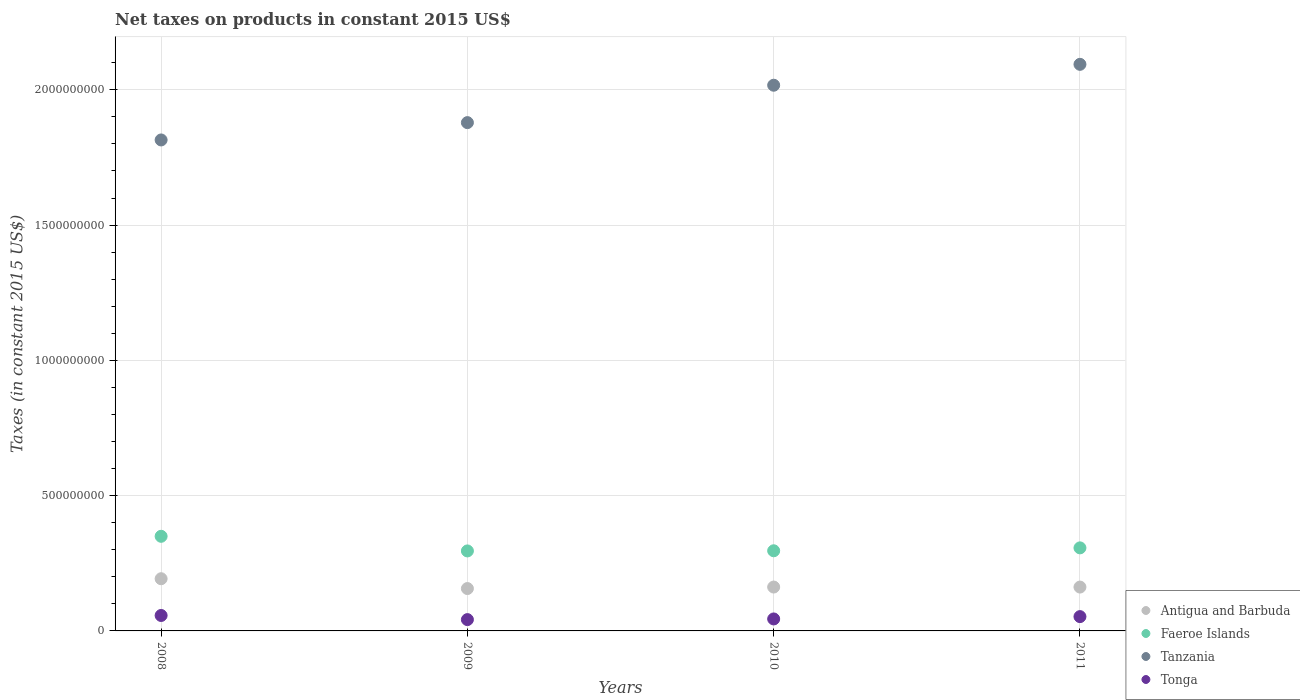Is the number of dotlines equal to the number of legend labels?
Your response must be concise. Yes. What is the net taxes on products in Antigua and Barbuda in 2011?
Make the answer very short. 1.62e+08. Across all years, what is the maximum net taxes on products in Tonga?
Offer a very short reply. 5.71e+07. Across all years, what is the minimum net taxes on products in Tanzania?
Provide a short and direct response. 1.81e+09. In which year was the net taxes on products in Tonga minimum?
Your answer should be compact. 2009. What is the total net taxes on products in Tanzania in the graph?
Ensure brevity in your answer.  7.80e+09. What is the difference between the net taxes on products in Antigua and Barbuda in 2008 and that in 2009?
Provide a succinct answer. 3.63e+07. What is the difference between the net taxes on products in Faeroe Islands in 2011 and the net taxes on products in Antigua and Barbuda in 2010?
Provide a succinct answer. 1.45e+08. What is the average net taxes on products in Tonga per year?
Make the answer very short. 4.90e+07. In the year 2010, what is the difference between the net taxes on products in Tanzania and net taxes on products in Antigua and Barbuda?
Provide a succinct answer. 1.85e+09. In how many years, is the net taxes on products in Faeroe Islands greater than 1600000000 US$?
Make the answer very short. 0. What is the ratio of the net taxes on products in Tanzania in 2009 to that in 2010?
Your answer should be very brief. 0.93. Is the difference between the net taxes on products in Tanzania in 2009 and 2011 greater than the difference between the net taxes on products in Antigua and Barbuda in 2009 and 2011?
Your answer should be compact. No. What is the difference between the highest and the second highest net taxes on products in Tanzania?
Your answer should be very brief. 7.72e+07. What is the difference between the highest and the lowest net taxes on products in Faeroe Islands?
Provide a succinct answer. 5.41e+07. In how many years, is the net taxes on products in Tanzania greater than the average net taxes on products in Tanzania taken over all years?
Keep it short and to the point. 2. Is it the case that in every year, the sum of the net taxes on products in Faeroe Islands and net taxes on products in Antigua and Barbuda  is greater than the net taxes on products in Tanzania?
Your response must be concise. No. Does the net taxes on products in Antigua and Barbuda monotonically increase over the years?
Offer a very short reply. No. Is the net taxes on products in Tanzania strictly greater than the net taxes on products in Antigua and Barbuda over the years?
Keep it short and to the point. Yes. Is the net taxes on products in Faeroe Islands strictly less than the net taxes on products in Tonga over the years?
Provide a short and direct response. No. How many years are there in the graph?
Provide a succinct answer. 4. What is the difference between two consecutive major ticks on the Y-axis?
Your response must be concise. 5.00e+08. Are the values on the major ticks of Y-axis written in scientific E-notation?
Provide a succinct answer. No. How many legend labels are there?
Provide a succinct answer. 4. How are the legend labels stacked?
Keep it short and to the point. Vertical. What is the title of the graph?
Your answer should be compact. Net taxes on products in constant 2015 US$. What is the label or title of the X-axis?
Your response must be concise. Years. What is the label or title of the Y-axis?
Keep it short and to the point. Taxes (in constant 2015 US$). What is the Taxes (in constant 2015 US$) in Antigua and Barbuda in 2008?
Your response must be concise. 1.93e+08. What is the Taxes (in constant 2015 US$) of Faeroe Islands in 2008?
Give a very brief answer. 3.50e+08. What is the Taxes (in constant 2015 US$) of Tanzania in 2008?
Ensure brevity in your answer.  1.81e+09. What is the Taxes (in constant 2015 US$) in Tonga in 2008?
Your answer should be very brief. 5.71e+07. What is the Taxes (in constant 2015 US$) of Antigua and Barbuda in 2009?
Keep it short and to the point. 1.57e+08. What is the Taxes (in constant 2015 US$) of Faeroe Islands in 2009?
Provide a succinct answer. 2.96e+08. What is the Taxes (in constant 2015 US$) of Tanzania in 2009?
Your answer should be compact. 1.88e+09. What is the Taxes (in constant 2015 US$) in Tonga in 2009?
Offer a very short reply. 4.18e+07. What is the Taxes (in constant 2015 US$) of Antigua and Barbuda in 2010?
Ensure brevity in your answer.  1.62e+08. What is the Taxes (in constant 2015 US$) in Faeroe Islands in 2010?
Provide a succinct answer. 2.96e+08. What is the Taxes (in constant 2015 US$) in Tanzania in 2010?
Keep it short and to the point. 2.02e+09. What is the Taxes (in constant 2015 US$) of Tonga in 2010?
Your answer should be very brief. 4.43e+07. What is the Taxes (in constant 2015 US$) in Antigua and Barbuda in 2011?
Ensure brevity in your answer.  1.62e+08. What is the Taxes (in constant 2015 US$) of Faeroe Islands in 2011?
Your response must be concise. 3.07e+08. What is the Taxes (in constant 2015 US$) of Tanzania in 2011?
Give a very brief answer. 2.09e+09. What is the Taxes (in constant 2015 US$) in Tonga in 2011?
Your response must be concise. 5.29e+07. Across all years, what is the maximum Taxes (in constant 2015 US$) of Antigua and Barbuda?
Provide a short and direct response. 1.93e+08. Across all years, what is the maximum Taxes (in constant 2015 US$) of Faeroe Islands?
Your answer should be compact. 3.50e+08. Across all years, what is the maximum Taxes (in constant 2015 US$) of Tanzania?
Provide a short and direct response. 2.09e+09. Across all years, what is the maximum Taxes (in constant 2015 US$) of Tonga?
Your answer should be very brief. 5.71e+07. Across all years, what is the minimum Taxes (in constant 2015 US$) of Antigua and Barbuda?
Make the answer very short. 1.57e+08. Across all years, what is the minimum Taxes (in constant 2015 US$) of Faeroe Islands?
Your answer should be compact. 2.96e+08. Across all years, what is the minimum Taxes (in constant 2015 US$) of Tanzania?
Your answer should be very brief. 1.81e+09. Across all years, what is the minimum Taxes (in constant 2015 US$) of Tonga?
Offer a terse response. 4.18e+07. What is the total Taxes (in constant 2015 US$) of Antigua and Barbuda in the graph?
Provide a short and direct response. 6.74e+08. What is the total Taxes (in constant 2015 US$) of Faeroe Islands in the graph?
Offer a very short reply. 1.25e+09. What is the total Taxes (in constant 2015 US$) of Tanzania in the graph?
Make the answer very short. 7.80e+09. What is the total Taxes (in constant 2015 US$) in Tonga in the graph?
Ensure brevity in your answer.  1.96e+08. What is the difference between the Taxes (in constant 2015 US$) of Antigua and Barbuda in 2008 and that in 2009?
Provide a short and direct response. 3.63e+07. What is the difference between the Taxes (in constant 2015 US$) of Faeroe Islands in 2008 and that in 2009?
Your answer should be very brief. 5.41e+07. What is the difference between the Taxes (in constant 2015 US$) in Tanzania in 2008 and that in 2009?
Your response must be concise. -6.40e+07. What is the difference between the Taxes (in constant 2015 US$) in Tonga in 2008 and that in 2009?
Ensure brevity in your answer.  1.53e+07. What is the difference between the Taxes (in constant 2015 US$) of Antigua and Barbuda in 2008 and that in 2010?
Offer a very short reply. 3.07e+07. What is the difference between the Taxes (in constant 2015 US$) in Faeroe Islands in 2008 and that in 2010?
Offer a terse response. 5.35e+07. What is the difference between the Taxes (in constant 2015 US$) of Tanzania in 2008 and that in 2010?
Give a very brief answer. -2.02e+08. What is the difference between the Taxes (in constant 2015 US$) of Tonga in 2008 and that in 2010?
Provide a succinct answer. 1.28e+07. What is the difference between the Taxes (in constant 2015 US$) of Antigua and Barbuda in 2008 and that in 2011?
Provide a short and direct response. 3.08e+07. What is the difference between the Taxes (in constant 2015 US$) in Faeroe Islands in 2008 and that in 2011?
Ensure brevity in your answer.  4.28e+07. What is the difference between the Taxes (in constant 2015 US$) in Tanzania in 2008 and that in 2011?
Keep it short and to the point. -2.79e+08. What is the difference between the Taxes (in constant 2015 US$) of Tonga in 2008 and that in 2011?
Your response must be concise. 4.20e+06. What is the difference between the Taxes (in constant 2015 US$) in Antigua and Barbuda in 2009 and that in 2010?
Offer a very short reply. -5.54e+06. What is the difference between the Taxes (in constant 2015 US$) in Faeroe Islands in 2009 and that in 2010?
Ensure brevity in your answer.  -5.65e+05. What is the difference between the Taxes (in constant 2015 US$) of Tanzania in 2009 and that in 2010?
Provide a succinct answer. -1.38e+08. What is the difference between the Taxes (in constant 2015 US$) of Tonga in 2009 and that in 2010?
Make the answer very short. -2.45e+06. What is the difference between the Taxes (in constant 2015 US$) of Antigua and Barbuda in 2009 and that in 2011?
Make the answer very short. -5.46e+06. What is the difference between the Taxes (in constant 2015 US$) of Faeroe Islands in 2009 and that in 2011?
Your response must be concise. -1.13e+07. What is the difference between the Taxes (in constant 2015 US$) in Tanzania in 2009 and that in 2011?
Your response must be concise. -2.15e+08. What is the difference between the Taxes (in constant 2015 US$) of Tonga in 2009 and that in 2011?
Your answer should be compact. -1.11e+07. What is the difference between the Taxes (in constant 2015 US$) in Antigua and Barbuda in 2010 and that in 2011?
Offer a very short reply. 8.18e+04. What is the difference between the Taxes (in constant 2015 US$) in Faeroe Islands in 2010 and that in 2011?
Offer a very short reply. -1.07e+07. What is the difference between the Taxes (in constant 2015 US$) in Tanzania in 2010 and that in 2011?
Make the answer very short. -7.72e+07. What is the difference between the Taxes (in constant 2015 US$) of Tonga in 2010 and that in 2011?
Give a very brief answer. -8.62e+06. What is the difference between the Taxes (in constant 2015 US$) in Antigua and Barbuda in 2008 and the Taxes (in constant 2015 US$) in Faeroe Islands in 2009?
Your answer should be compact. -1.03e+08. What is the difference between the Taxes (in constant 2015 US$) in Antigua and Barbuda in 2008 and the Taxes (in constant 2015 US$) in Tanzania in 2009?
Keep it short and to the point. -1.69e+09. What is the difference between the Taxes (in constant 2015 US$) in Antigua and Barbuda in 2008 and the Taxes (in constant 2015 US$) in Tonga in 2009?
Ensure brevity in your answer.  1.51e+08. What is the difference between the Taxes (in constant 2015 US$) in Faeroe Islands in 2008 and the Taxes (in constant 2015 US$) in Tanzania in 2009?
Make the answer very short. -1.53e+09. What is the difference between the Taxes (in constant 2015 US$) in Faeroe Islands in 2008 and the Taxes (in constant 2015 US$) in Tonga in 2009?
Your answer should be compact. 3.08e+08. What is the difference between the Taxes (in constant 2015 US$) of Tanzania in 2008 and the Taxes (in constant 2015 US$) of Tonga in 2009?
Provide a succinct answer. 1.77e+09. What is the difference between the Taxes (in constant 2015 US$) in Antigua and Barbuda in 2008 and the Taxes (in constant 2015 US$) in Faeroe Islands in 2010?
Your response must be concise. -1.03e+08. What is the difference between the Taxes (in constant 2015 US$) of Antigua and Barbuda in 2008 and the Taxes (in constant 2015 US$) of Tanzania in 2010?
Give a very brief answer. -1.82e+09. What is the difference between the Taxes (in constant 2015 US$) in Antigua and Barbuda in 2008 and the Taxes (in constant 2015 US$) in Tonga in 2010?
Your response must be concise. 1.49e+08. What is the difference between the Taxes (in constant 2015 US$) in Faeroe Islands in 2008 and the Taxes (in constant 2015 US$) in Tanzania in 2010?
Provide a short and direct response. -1.67e+09. What is the difference between the Taxes (in constant 2015 US$) of Faeroe Islands in 2008 and the Taxes (in constant 2015 US$) of Tonga in 2010?
Provide a succinct answer. 3.05e+08. What is the difference between the Taxes (in constant 2015 US$) in Tanzania in 2008 and the Taxes (in constant 2015 US$) in Tonga in 2010?
Your answer should be compact. 1.77e+09. What is the difference between the Taxes (in constant 2015 US$) in Antigua and Barbuda in 2008 and the Taxes (in constant 2015 US$) in Faeroe Islands in 2011?
Your answer should be very brief. -1.14e+08. What is the difference between the Taxes (in constant 2015 US$) in Antigua and Barbuda in 2008 and the Taxes (in constant 2015 US$) in Tanzania in 2011?
Offer a terse response. -1.90e+09. What is the difference between the Taxes (in constant 2015 US$) of Antigua and Barbuda in 2008 and the Taxes (in constant 2015 US$) of Tonga in 2011?
Your answer should be compact. 1.40e+08. What is the difference between the Taxes (in constant 2015 US$) of Faeroe Islands in 2008 and the Taxes (in constant 2015 US$) of Tanzania in 2011?
Provide a succinct answer. -1.74e+09. What is the difference between the Taxes (in constant 2015 US$) of Faeroe Islands in 2008 and the Taxes (in constant 2015 US$) of Tonga in 2011?
Provide a succinct answer. 2.97e+08. What is the difference between the Taxes (in constant 2015 US$) of Tanzania in 2008 and the Taxes (in constant 2015 US$) of Tonga in 2011?
Your response must be concise. 1.76e+09. What is the difference between the Taxes (in constant 2015 US$) in Antigua and Barbuda in 2009 and the Taxes (in constant 2015 US$) in Faeroe Islands in 2010?
Keep it short and to the point. -1.40e+08. What is the difference between the Taxes (in constant 2015 US$) of Antigua and Barbuda in 2009 and the Taxes (in constant 2015 US$) of Tanzania in 2010?
Provide a succinct answer. -1.86e+09. What is the difference between the Taxes (in constant 2015 US$) of Antigua and Barbuda in 2009 and the Taxes (in constant 2015 US$) of Tonga in 2010?
Keep it short and to the point. 1.12e+08. What is the difference between the Taxes (in constant 2015 US$) of Faeroe Islands in 2009 and the Taxes (in constant 2015 US$) of Tanzania in 2010?
Offer a very short reply. -1.72e+09. What is the difference between the Taxes (in constant 2015 US$) in Faeroe Islands in 2009 and the Taxes (in constant 2015 US$) in Tonga in 2010?
Your answer should be very brief. 2.51e+08. What is the difference between the Taxes (in constant 2015 US$) in Tanzania in 2009 and the Taxes (in constant 2015 US$) in Tonga in 2010?
Keep it short and to the point. 1.83e+09. What is the difference between the Taxes (in constant 2015 US$) in Antigua and Barbuda in 2009 and the Taxes (in constant 2015 US$) in Faeroe Islands in 2011?
Offer a very short reply. -1.50e+08. What is the difference between the Taxes (in constant 2015 US$) in Antigua and Barbuda in 2009 and the Taxes (in constant 2015 US$) in Tanzania in 2011?
Your response must be concise. -1.94e+09. What is the difference between the Taxes (in constant 2015 US$) of Antigua and Barbuda in 2009 and the Taxes (in constant 2015 US$) of Tonga in 2011?
Provide a short and direct response. 1.04e+08. What is the difference between the Taxes (in constant 2015 US$) in Faeroe Islands in 2009 and the Taxes (in constant 2015 US$) in Tanzania in 2011?
Give a very brief answer. -1.80e+09. What is the difference between the Taxes (in constant 2015 US$) of Faeroe Islands in 2009 and the Taxes (in constant 2015 US$) of Tonga in 2011?
Keep it short and to the point. 2.43e+08. What is the difference between the Taxes (in constant 2015 US$) in Tanzania in 2009 and the Taxes (in constant 2015 US$) in Tonga in 2011?
Your response must be concise. 1.83e+09. What is the difference between the Taxes (in constant 2015 US$) in Antigua and Barbuda in 2010 and the Taxes (in constant 2015 US$) in Faeroe Islands in 2011?
Your answer should be very brief. -1.45e+08. What is the difference between the Taxes (in constant 2015 US$) of Antigua and Barbuda in 2010 and the Taxes (in constant 2015 US$) of Tanzania in 2011?
Provide a succinct answer. -1.93e+09. What is the difference between the Taxes (in constant 2015 US$) of Antigua and Barbuda in 2010 and the Taxes (in constant 2015 US$) of Tonga in 2011?
Offer a very short reply. 1.09e+08. What is the difference between the Taxes (in constant 2015 US$) of Faeroe Islands in 2010 and the Taxes (in constant 2015 US$) of Tanzania in 2011?
Your answer should be very brief. -1.80e+09. What is the difference between the Taxes (in constant 2015 US$) in Faeroe Islands in 2010 and the Taxes (in constant 2015 US$) in Tonga in 2011?
Provide a short and direct response. 2.43e+08. What is the difference between the Taxes (in constant 2015 US$) of Tanzania in 2010 and the Taxes (in constant 2015 US$) of Tonga in 2011?
Provide a short and direct response. 1.96e+09. What is the average Taxes (in constant 2015 US$) of Antigua and Barbuda per year?
Give a very brief answer. 1.68e+08. What is the average Taxes (in constant 2015 US$) of Faeroe Islands per year?
Your answer should be very brief. 3.12e+08. What is the average Taxes (in constant 2015 US$) of Tanzania per year?
Provide a succinct answer. 1.95e+09. What is the average Taxes (in constant 2015 US$) in Tonga per year?
Your answer should be very brief. 4.90e+07. In the year 2008, what is the difference between the Taxes (in constant 2015 US$) in Antigua and Barbuda and Taxes (in constant 2015 US$) in Faeroe Islands?
Provide a short and direct response. -1.57e+08. In the year 2008, what is the difference between the Taxes (in constant 2015 US$) in Antigua and Barbuda and Taxes (in constant 2015 US$) in Tanzania?
Offer a terse response. -1.62e+09. In the year 2008, what is the difference between the Taxes (in constant 2015 US$) in Antigua and Barbuda and Taxes (in constant 2015 US$) in Tonga?
Ensure brevity in your answer.  1.36e+08. In the year 2008, what is the difference between the Taxes (in constant 2015 US$) in Faeroe Islands and Taxes (in constant 2015 US$) in Tanzania?
Your answer should be compact. -1.46e+09. In the year 2008, what is the difference between the Taxes (in constant 2015 US$) in Faeroe Islands and Taxes (in constant 2015 US$) in Tonga?
Your response must be concise. 2.93e+08. In the year 2008, what is the difference between the Taxes (in constant 2015 US$) in Tanzania and Taxes (in constant 2015 US$) in Tonga?
Give a very brief answer. 1.76e+09. In the year 2009, what is the difference between the Taxes (in constant 2015 US$) of Antigua and Barbuda and Taxes (in constant 2015 US$) of Faeroe Islands?
Keep it short and to the point. -1.39e+08. In the year 2009, what is the difference between the Taxes (in constant 2015 US$) of Antigua and Barbuda and Taxes (in constant 2015 US$) of Tanzania?
Provide a succinct answer. -1.72e+09. In the year 2009, what is the difference between the Taxes (in constant 2015 US$) of Antigua and Barbuda and Taxes (in constant 2015 US$) of Tonga?
Ensure brevity in your answer.  1.15e+08. In the year 2009, what is the difference between the Taxes (in constant 2015 US$) of Faeroe Islands and Taxes (in constant 2015 US$) of Tanzania?
Give a very brief answer. -1.58e+09. In the year 2009, what is the difference between the Taxes (in constant 2015 US$) of Faeroe Islands and Taxes (in constant 2015 US$) of Tonga?
Your answer should be very brief. 2.54e+08. In the year 2009, what is the difference between the Taxes (in constant 2015 US$) of Tanzania and Taxes (in constant 2015 US$) of Tonga?
Give a very brief answer. 1.84e+09. In the year 2010, what is the difference between the Taxes (in constant 2015 US$) in Antigua and Barbuda and Taxes (in constant 2015 US$) in Faeroe Islands?
Offer a terse response. -1.34e+08. In the year 2010, what is the difference between the Taxes (in constant 2015 US$) of Antigua and Barbuda and Taxes (in constant 2015 US$) of Tanzania?
Give a very brief answer. -1.85e+09. In the year 2010, what is the difference between the Taxes (in constant 2015 US$) in Antigua and Barbuda and Taxes (in constant 2015 US$) in Tonga?
Offer a very short reply. 1.18e+08. In the year 2010, what is the difference between the Taxes (in constant 2015 US$) in Faeroe Islands and Taxes (in constant 2015 US$) in Tanzania?
Make the answer very short. -1.72e+09. In the year 2010, what is the difference between the Taxes (in constant 2015 US$) in Faeroe Islands and Taxes (in constant 2015 US$) in Tonga?
Offer a terse response. 2.52e+08. In the year 2010, what is the difference between the Taxes (in constant 2015 US$) in Tanzania and Taxes (in constant 2015 US$) in Tonga?
Offer a terse response. 1.97e+09. In the year 2011, what is the difference between the Taxes (in constant 2015 US$) in Antigua and Barbuda and Taxes (in constant 2015 US$) in Faeroe Islands?
Give a very brief answer. -1.45e+08. In the year 2011, what is the difference between the Taxes (in constant 2015 US$) of Antigua and Barbuda and Taxes (in constant 2015 US$) of Tanzania?
Your answer should be very brief. -1.93e+09. In the year 2011, what is the difference between the Taxes (in constant 2015 US$) in Antigua and Barbuda and Taxes (in constant 2015 US$) in Tonga?
Your answer should be very brief. 1.09e+08. In the year 2011, what is the difference between the Taxes (in constant 2015 US$) of Faeroe Islands and Taxes (in constant 2015 US$) of Tanzania?
Keep it short and to the point. -1.79e+09. In the year 2011, what is the difference between the Taxes (in constant 2015 US$) in Faeroe Islands and Taxes (in constant 2015 US$) in Tonga?
Make the answer very short. 2.54e+08. In the year 2011, what is the difference between the Taxes (in constant 2015 US$) in Tanzania and Taxes (in constant 2015 US$) in Tonga?
Make the answer very short. 2.04e+09. What is the ratio of the Taxes (in constant 2015 US$) in Antigua and Barbuda in 2008 to that in 2009?
Make the answer very short. 1.23. What is the ratio of the Taxes (in constant 2015 US$) of Faeroe Islands in 2008 to that in 2009?
Provide a succinct answer. 1.18. What is the ratio of the Taxes (in constant 2015 US$) of Tanzania in 2008 to that in 2009?
Your answer should be very brief. 0.97. What is the ratio of the Taxes (in constant 2015 US$) in Tonga in 2008 to that in 2009?
Provide a short and direct response. 1.37. What is the ratio of the Taxes (in constant 2015 US$) in Antigua and Barbuda in 2008 to that in 2010?
Your response must be concise. 1.19. What is the ratio of the Taxes (in constant 2015 US$) in Faeroe Islands in 2008 to that in 2010?
Give a very brief answer. 1.18. What is the ratio of the Taxes (in constant 2015 US$) in Tanzania in 2008 to that in 2010?
Make the answer very short. 0.9. What is the ratio of the Taxes (in constant 2015 US$) in Tonga in 2008 to that in 2010?
Provide a succinct answer. 1.29. What is the ratio of the Taxes (in constant 2015 US$) of Antigua and Barbuda in 2008 to that in 2011?
Provide a short and direct response. 1.19. What is the ratio of the Taxes (in constant 2015 US$) in Faeroe Islands in 2008 to that in 2011?
Offer a very short reply. 1.14. What is the ratio of the Taxes (in constant 2015 US$) of Tanzania in 2008 to that in 2011?
Ensure brevity in your answer.  0.87. What is the ratio of the Taxes (in constant 2015 US$) in Tonga in 2008 to that in 2011?
Your response must be concise. 1.08. What is the ratio of the Taxes (in constant 2015 US$) of Antigua and Barbuda in 2009 to that in 2010?
Offer a very short reply. 0.97. What is the ratio of the Taxes (in constant 2015 US$) in Tanzania in 2009 to that in 2010?
Offer a terse response. 0.93. What is the ratio of the Taxes (in constant 2015 US$) in Tonga in 2009 to that in 2010?
Make the answer very short. 0.94. What is the ratio of the Taxes (in constant 2015 US$) of Antigua and Barbuda in 2009 to that in 2011?
Ensure brevity in your answer.  0.97. What is the ratio of the Taxes (in constant 2015 US$) in Faeroe Islands in 2009 to that in 2011?
Your answer should be compact. 0.96. What is the ratio of the Taxes (in constant 2015 US$) of Tanzania in 2009 to that in 2011?
Your response must be concise. 0.9. What is the ratio of the Taxes (in constant 2015 US$) of Tonga in 2009 to that in 2011?
Make the answer very short. 0.79. What is the ratio of the Taxes (in constant 2015 US$) in Antigua and Barbuda in 2010 to that in 2011?
Your response must be concise. 1. What is the ratio of the Taxes (in constant 2015 US$) in Faeroe Islands in 2010 to that in 2011?
Keep it short and to the point. 0.96. What is the ratio of the Taxes (in constant 2015 US$) of Tanzania in 2010 to that in 2011?
Your answer should be very brief. 0.96. What is the ratio of the Taxes (in constant 2015 US$) in Tonga in 2010 to that in 2011?
Provide a succinct answer. 0.84. What is the difference between the highest and the second highest Taxes (in constant 2015 US$) in Antigua and Barbuda?
Ensure brevity in your answer.  3.07e+07. What is the difference between the highest and the second highest Taxes (in constant 2015 US$) of Faeroe Islands?
Provide a short and direct response. 4.28e+07. What is the difference between the highest and the second highest Taxes (in constant 2015 US$) in Tanzania?
Your response must be concise. 7.72e+07. What is the difference between the highest and the second highest Taxes (in constant 2015 US$) of Tonga?
Offer a terse response. 4.20e+06. What is the difference between the highest and the lowest Taxes (in constant 2015 US$) in Antigua and Barbuda?
Ensure brevity in your answer.  3.63e+07. What is the difference between the highest and the lowest Taxes (in constant 2015 US$) of Faeroe Islands?
Offer a terse response. 5.41e+07. What is the difference between the highest and the lowest Taxes (in constant 2015 US$) of Tanzania?
Your answer should be compact. 2.79e+08. What is the difference between the highest and the lowest Taxes (in constant 2015 US$) in Tonga?
Provide a succinct answer. 1.53e+07. 